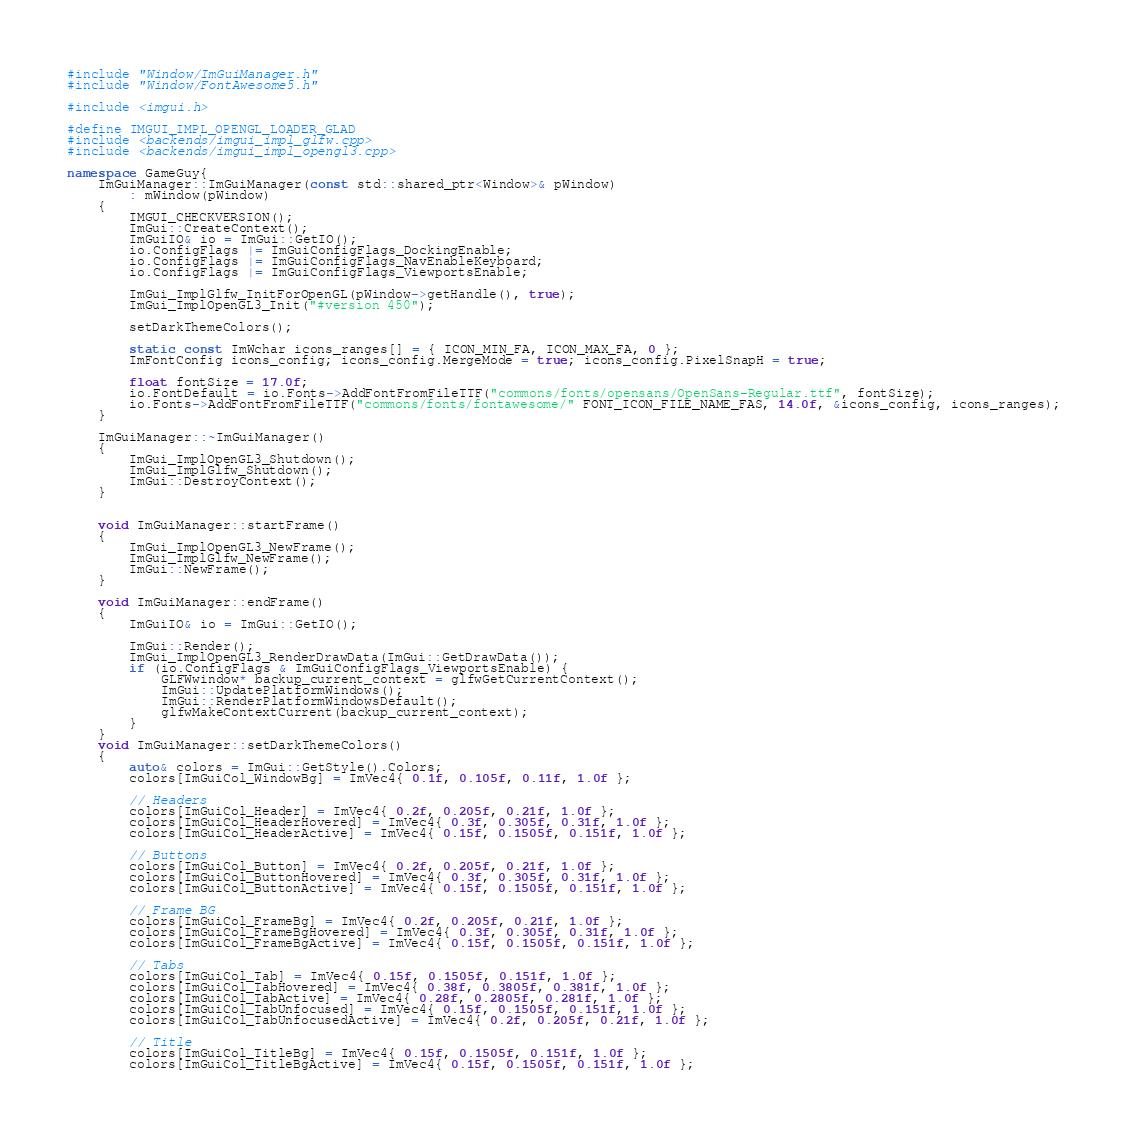Convert code to text. <code><loc_0><loc_0><loc_500><loc_500><_C++_>#include "Window/ImGuiManager.h"
#include "Window/FontAwesome5.h"

#include <imgui.h>

#define IMGUI_IMPL_OPENGL_LOADER_GLAD
#include <backends/imgui_impl_glfw.cpp>
#include <backends/imgui_impl_opengl3.cpp>

namespace GameGuy{
	ImGuiManager::ImGuiManager(const std::shared_ptr<Window>& pWindow)
		: mWindow(pWindow)
	{
		IMGUI_CHECKVERSION();
		ImGui::CreateContext();
		ImGuiIO& io = ImGui::GetIO();
		io.ConfigFlags |= ImGuiConfigFlags_DockingEnable;
		io.ConfigFlags |= ImGuiConfigFlags_NavEnableKeyboard;
		io.ConfigFlags |= ImGuiConfigFlags_ViewportsEnable;

		ImGui_ImplGlfw_InitForOpenGL(pWindow->getHandle(), true);
		ImGui_ImplOpenGL3_Init("#version 450");

		setDarkThemeColors();

		static const ImWchar icons_ranges[] = { ICON_MIN_FA, ICON_MAX_FA, 0 };
		ImFontConfig icons_config; icons_config.MergeMode = true; icons_config.PixelSnapH = true;

		float fontSize = 17.0f;
		io.FontDefault = io.Fonts->AddFontFromFileTTF("commons/fonts/opensans/OpenSans-Regular.ttf", fontSize);
		io.Fonts->AddFontFromFileTTF("commons/fonts/fontawesome/" FONT_ICON_FILE_NAME_FAS, 14.0f, &icons_config, icons_ranges);
	}

	ImGuiManager::~ImGuiManager()
	{
		ImGui_ImplOpenGL3_Shutdown();
		ImGui_ImplGlfw_Shutdown();
		ImGui::DestroyContext();
	}


	void ImGuiManager::startFrame()
	{
		ImGui_ImplOpenGL3_NewFrame();
		ImGui_ImplGlfw_NewFrame();
		ImGui::NewFrame();
	}

	void ImGuiManager::endFrame()
	{
		ImGuiIO& io = ImGui::GetIO();

		ImGui::Render();
		ImGui_ImplOpenGL3_RenderDrawData(ImGui::GetDrawData());
		if (io.ConfigFlags & ImGuiConfigFlags_ViewportsEnable) {
			GLFWwindow* backup_current_context = glfwGetCurrentContext();
			ImGui::UpdatePlatformWindows();
			ImGui::RenderPlatformWindowsDefault();
			glfwMakeContextCurrent(backup_current_context);
		}
	}
	void ImGuiManager::setDarkThemeColors()
	{
		auto& colors = ImGui::GetStyle().Colors;
		colors[ImGuiCol_WindowBg] = ImVec4{ 0.1f, 0.105f, 0.11f, 1.0f };

		// Headers
		colors[ImGuiCol_Header] = ImVec4{ 0.2f, 0.205f, 0.21f, 1.0f };
		colors[ImGuiCol_HeaderHovered] = ImVec4{ 0.3f, 0.305f, 0.31f, 1.0f };
		colors[ImGuiCol_HeaderActive] = ImVec4{ 0.15f, 0.1505f, 0.151f, 1.0f };

		// Buttons
		colors[ImGuiCol_Button] = ImVec4{ 0.2f, 0.205f, 0.21f, 1.0f };
		colors[ImGuiCol_ButtonHovered] = ImVec4{ 0.3f, 0.305f, 0.31f, 1.0f };
		colors[ImGuiCol_ButtonActive] = ImVec4{ 0.15f, 0.1505f, 0.151f, 1.0f };

		// Frame BG
		colors[ImGuiCol_FrameBg] = ImVec4{ 0.2f, 0.205f, 0.21f, 1.0f };
		colors[ImGuiCol_FrameBgHovered] = ImVec4{ 0.3f, 0.305f, 0.31f, 1.0f };
		colors[ImGuiCol_FrameBgActive] = ImVec4{ 0.15f, 0.1505f, 0.151f, 1.0f };

		// Tabs
		colors[ImGuiCol_Tab] = ImVec4{ 0.15f, 0.1505f, 0.151f, 1.0f };
		colors[ImGuiCol_TabHovered] = ImVec4{ 0.38f, 0.3805f, 0.381f, 1.0f };
		colors[ImGuiCol_TabActive] = ImVec4{ 0.28f, 0.2805f, 0.281f, 1.0f };
		colors[ImGuiCol_TabUnfocused] = ImVec4{ 0.15f, 0.1505f, 0.151f, 1.0f };
		colors[ImGuiCol_TabUnfocusedActive] = ImVec4{ 0.2f, 0.205f, 0.21f, 1.0f };

		// Title
		colors[ImGuiCol_TitleBg] = ImVec4{ 0.15f, 0.1505f, 0.151f, 1.0f };
		colors[ImGuiCol_TitleBgActive] = ImVec4{ 0.15f, 0.1505f, 0.151f, 1.0f };</code> 